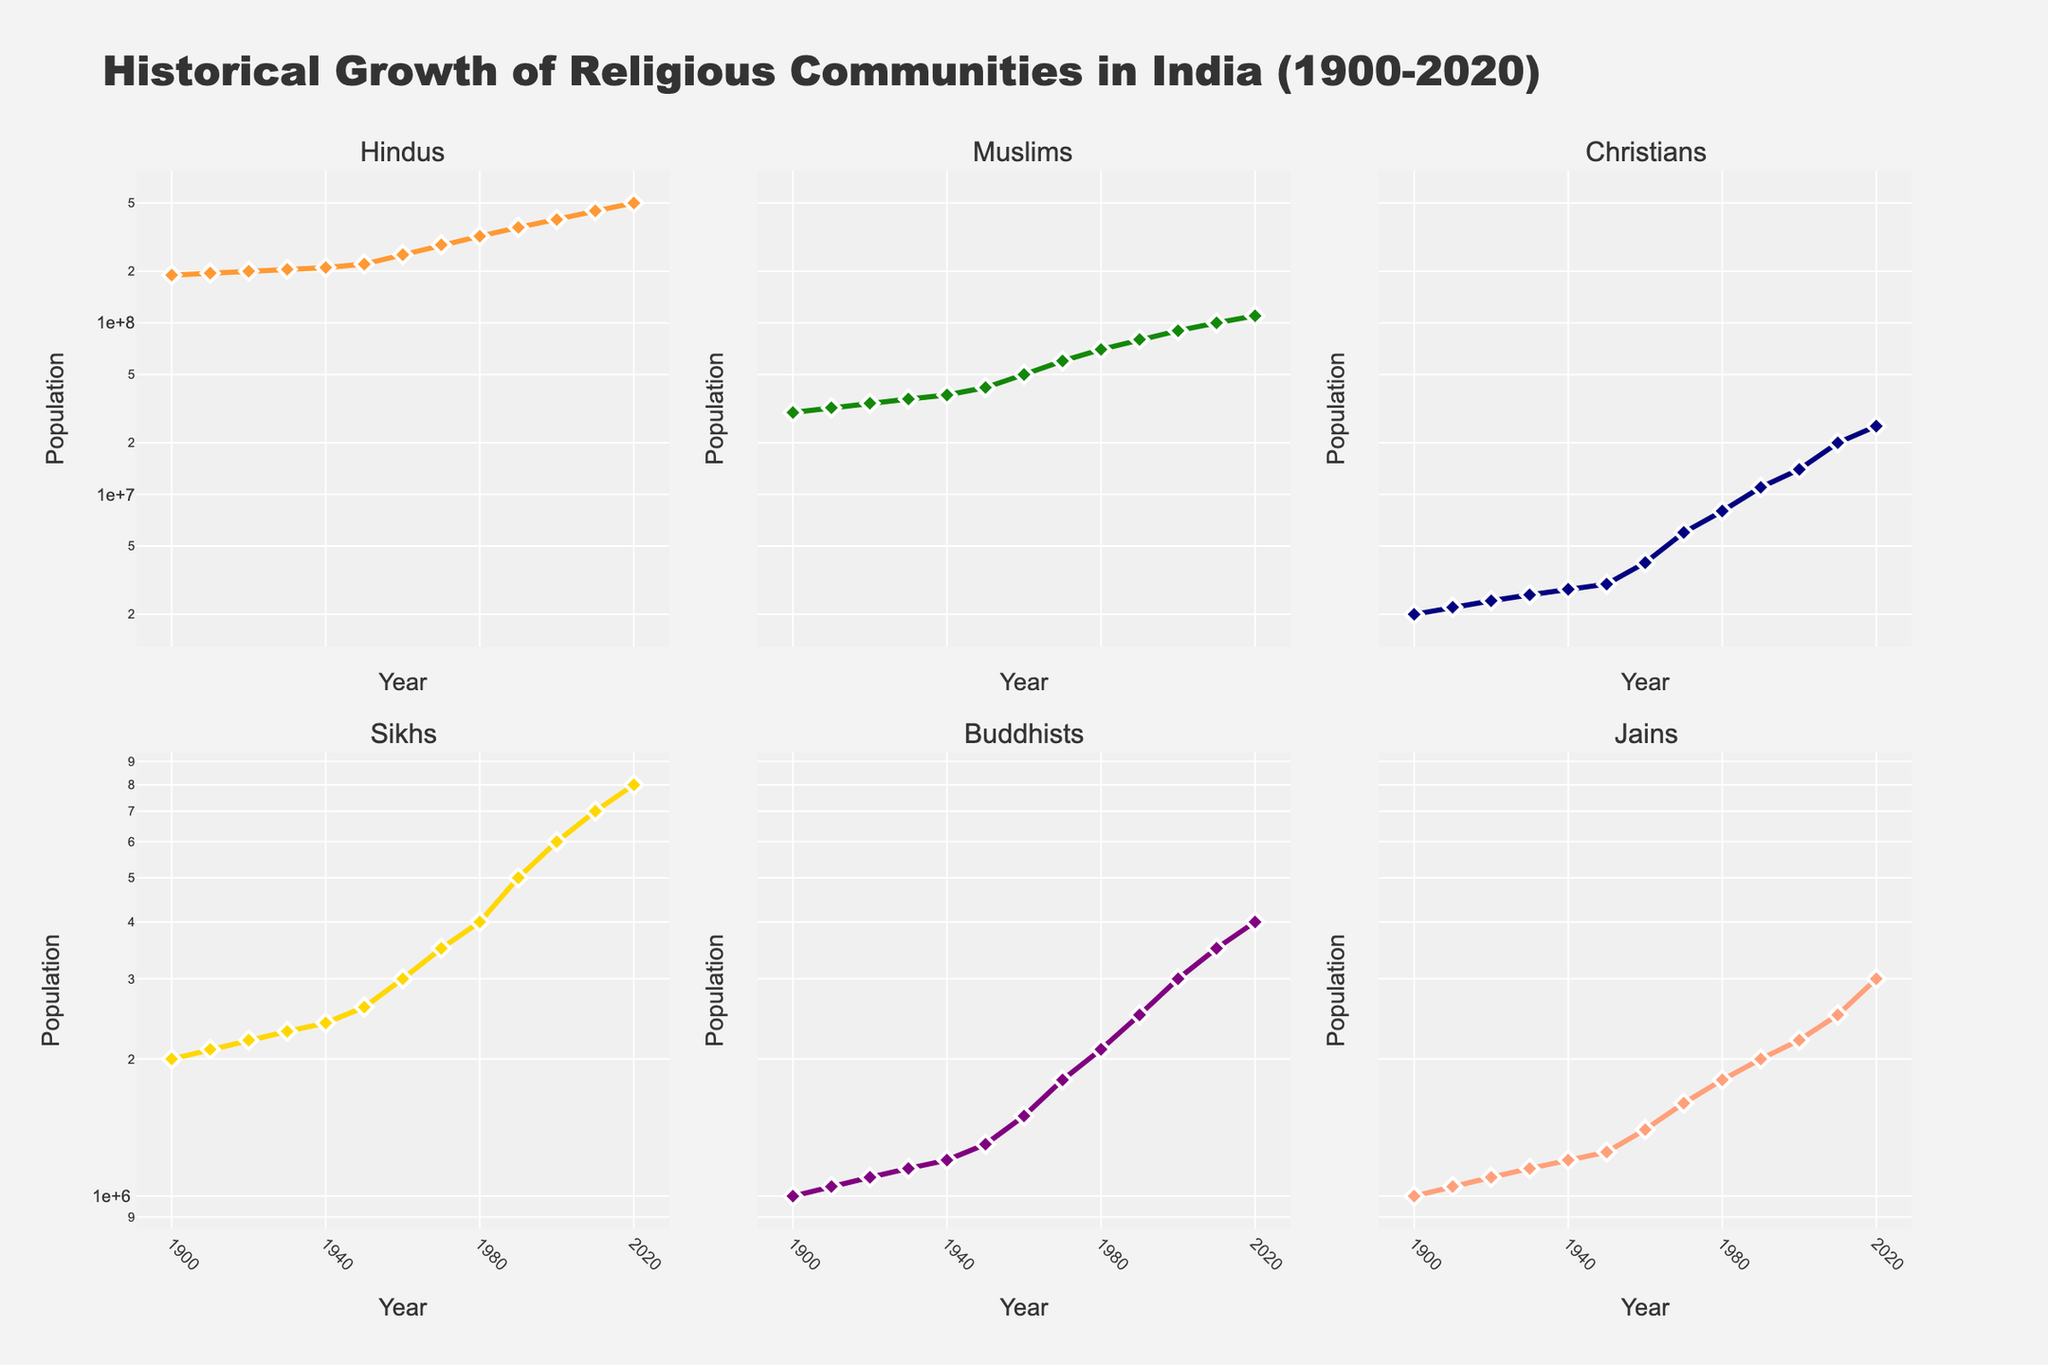what is the overall trend for the Hindus' population from 1900 to 2020? The overall trend for the Hindu population from 1900 to 2020 shows a consistent increase. By looking at the plot associated with Hindus, we can see a steady upward trajectory from 190 million in 1900 to 500 million in 2020.
Answer: Steady increase what is the population of Jains in 2020 compared to 1900? In 1900, the population of Jains was 1,000,000. By 2020, it had increased to 3,000,000. By comparing these two values, we can see that the Jain population tripled over this period.
Answer: Tripled Which religious community had the fastest growth rate from 1900 to 2020? By comparing the initial and final population values for each community and considering the log scale on the y-axis, we can observe that Muslins grew from 30 million in 1900 to 110 million in 2020, which demonstrates one of the fastest growth rates among the listed communities.
Answer: Muslims How did the Sikh population change from 1950 to 2000? The Sikh population in 1950 was 2,600,000, and it increased to 6,000,000 by 2000. To understand the change, we subtract the 1950 value from the 2000 value, resulting in an increase of 3,400,000.
Answer: Increased by 3,400,000 Which religious community had the least population growth from 1900 to 2020? By observing the initial and final population values and considering the log scale, we can see that the Jain community had the least population growth, starting from 1,000,000 in 1900 and reaching 3,000,000 in 2020.
Answer: Jains What was the average increase per decade for Buddhists from 1900 to 2020? To find the average increase, we first observe the Buddhist population growth from 1,000,000 in 1900 to 4,000,000 in 2020, an overall increase of 3,000,000 over 120 years. Dividing this total increase by the number of decades (12), we get 3,000,000 / 12 = 250,000.
Answer: 250,000 How does the log scale affect the interpretation of population growth for the religious communities? The log scale compresses the vertical axis, which can make rapid growth rates appear more linear and less dramatic. This scale is beneficial for comparing growth rates across different magnitudes of population sizes, emphasizing relative changes rather than absolute differences.
Answer: Emphasizes relative changes Between which decades did the Muslim population experience the most rapid growth? By observing the plot for Muslims and noting the steepest part of the curve, the most rapid growth seems to occur between the 1950s and 1960s, where the population jumped from 42 million to 50 million.
Answer: 1950s to 1960s Which religious community had larger populations than Buddhists in 2020? By comparing the final values on the plots, communities such as Hindus, Muslims, Christians, and Sikhs had larger populations than Buddhists in 2020.
Answer: Hindus, Muslims, Christians, Sikhs 